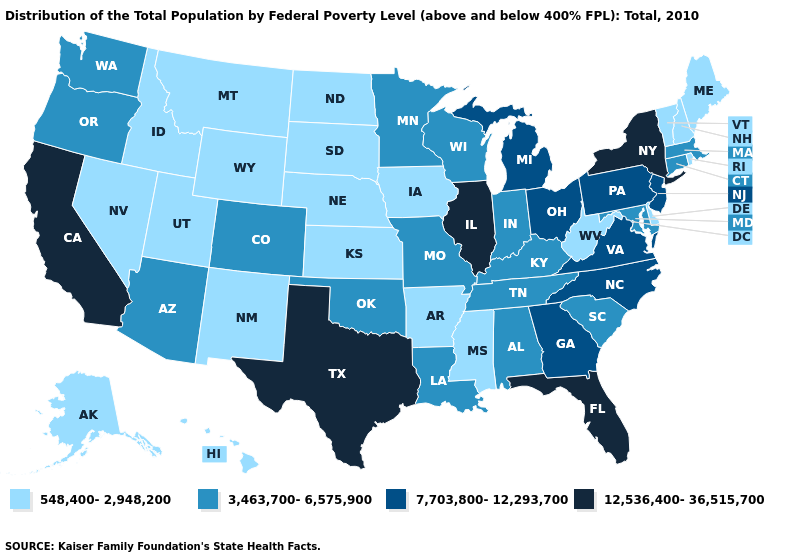What is the lowest value in the South?
Give a very brief answer. 548,400-2,948,200. What is the value of Indiana?
Quick response, please. 3,463,700-6,575,900. Name the states that have a value in the range 12,536,400-36,515,700?
Keep it brief. California, Florida, Illinois, New York, Texas. Does the first symbol in the legend represent the smallest category?
Keep it brief. Yes. Does New York have the lowest value in the Northeast?
Write a very short answer. No. Name the states that have a value in the range 548,400-2,948,200?
Be succinct. Alaska, Arkansas, Delaware, Hawaii, Idaho, Iowa, Kansas, Maine, Mississippi, Montana, Nebraska, Nevada, New Hampshire, New Mexico, North Dakota, Rhode Island, South Dakota, Utah, Vermont, West Virginia, Wyoming. Name the states that have a value in the range 7,703,800-12,293,700?
Answer briefly. Georgia, Michigan, New Jersey, North Carolina, Ohio, Pennsylvania, Virginia. Does Missouri have the lowest value in the USA?
Concise answer only. No. Does New Hampshire have a lower value than New Mexico?
Write a very short answer. No. What is the value of Indiana?
Give a very brief answer. 3,463,700-6,575,900. Which states have the lowest value in the USA?
Be succinct. Alaska, Arkansas, Delaware, Hawaii, Idaho, Iowa, Kansas, Maine, Mississippi, Montana, Nebraska, Nevada, New Hampshire, New Mexico, North Dakota, Rhode Island, South Dakota, Utah, Vermont, West Virginia, Wyoming. What is the lowest value in states that border Oregon?
Give a very brief answer. 548,400-2,948,200. Is the legend a continuous bar?
Write a very short answer. No. Does Maine have a lower value than Wyoming?
Write a very short answer. No. Among the states that border Vermont , which have the highest value?
Write a very short answer. New York. 